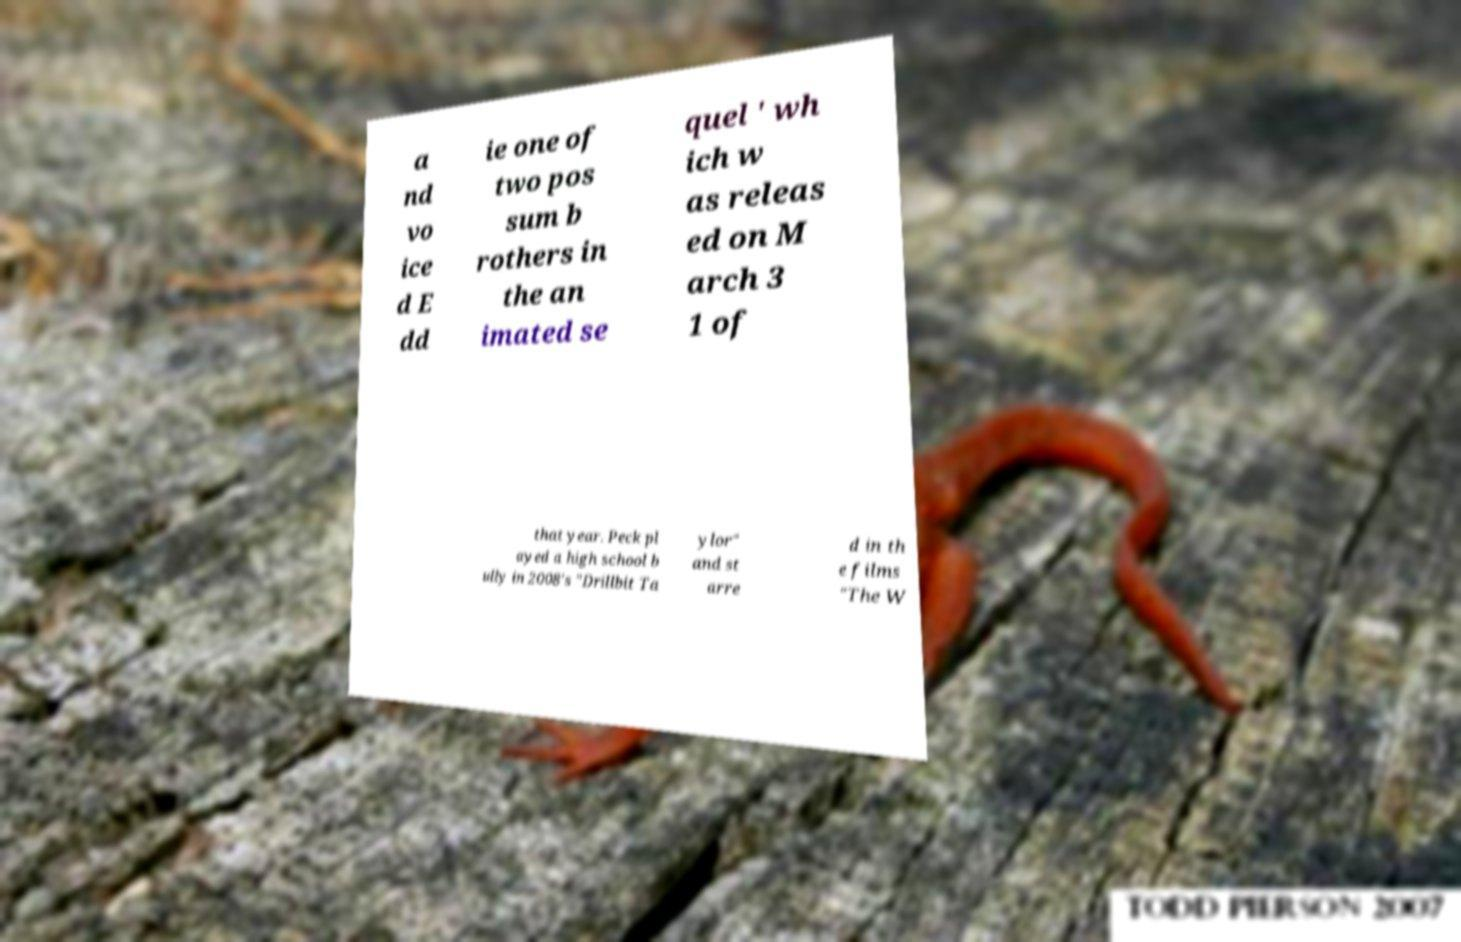There's text embedded in this image that I need extracted. Can you transcribe it verbatim? a nd vo ice d E dd ie one of two pos sum b rothers in the an imated se quel ' wh ich w as releas ed on M arch 3 1 of that year. Peck pl ayed a high school b ully in 2008's "Drillbit Ta ylor" and st arre d in th e films "The W 